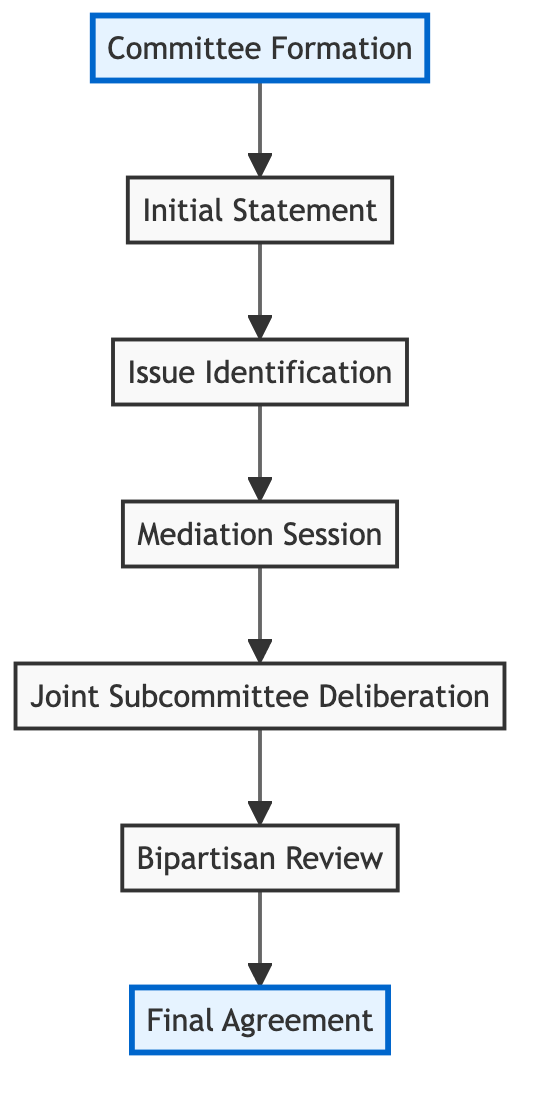What is the final outcome of the flowchart? The final outcome is the "Final Agreement." It can be found at the top of the diagram, indicating it is the last step after all previous elements have been completed.
Answer: Final Agreement How many stages are there in the conflict resolution process? The diagram shows six distinct stages starting from "Committee Formation" to "Final Agreement." By counting each node including the initial and final stages, we confirm there are six stages in total.
Answer: Six What is the first step in the flowchart? The first step outlined in the diagram is "Committee Formation," which is the starting point of the process.
Answer: Committee Formation Which step comes after "Mediation Session"? According to the flowchart, the next step after "Mediation Session" is "Joint Subcommittee Deliberation," which follows a sequential order within the process.
Answer: Joint Subcommittee Deliberation What is the relationship between "Bipartisan Review" and "Final Agreement"? The "Bipartisan Review" directly leads to the "Final Agreement," indicating that the review is a precursor to reaching an agreement among the parties involved.
Answer: Bipartisan Review leads to Final Agreement Which two steps come before "Joint Subcommittee Deliberation"? The steps that precede "Joint Subcommittee Deliberation" are "Mediation Session" and "Issue Identification." They contribute to the deliberation that occurs afterward.
Answer: Mediation Session, Issue Identification What role does "Issue Identification" play in the flowchart? "Issue Identification" is critical as it documents the key issues in conflict, serving as a necessary stage before mediation can take place in the diagram.
Answer: Key issues identification Is "Initial Statement" the last stage in the process? No, the "Initial Statement" is not the last stage. It is the second step in the sequence of the flowchart, leading to "Issue Identification" subsequently.
Answer: No How many times does the word "Session" appear in the flowchart? The word "Session" appears two times in the flowchart, specifically in "Mediation Session" and "Joint Subcommittee Deliberation."
Answer: Two 